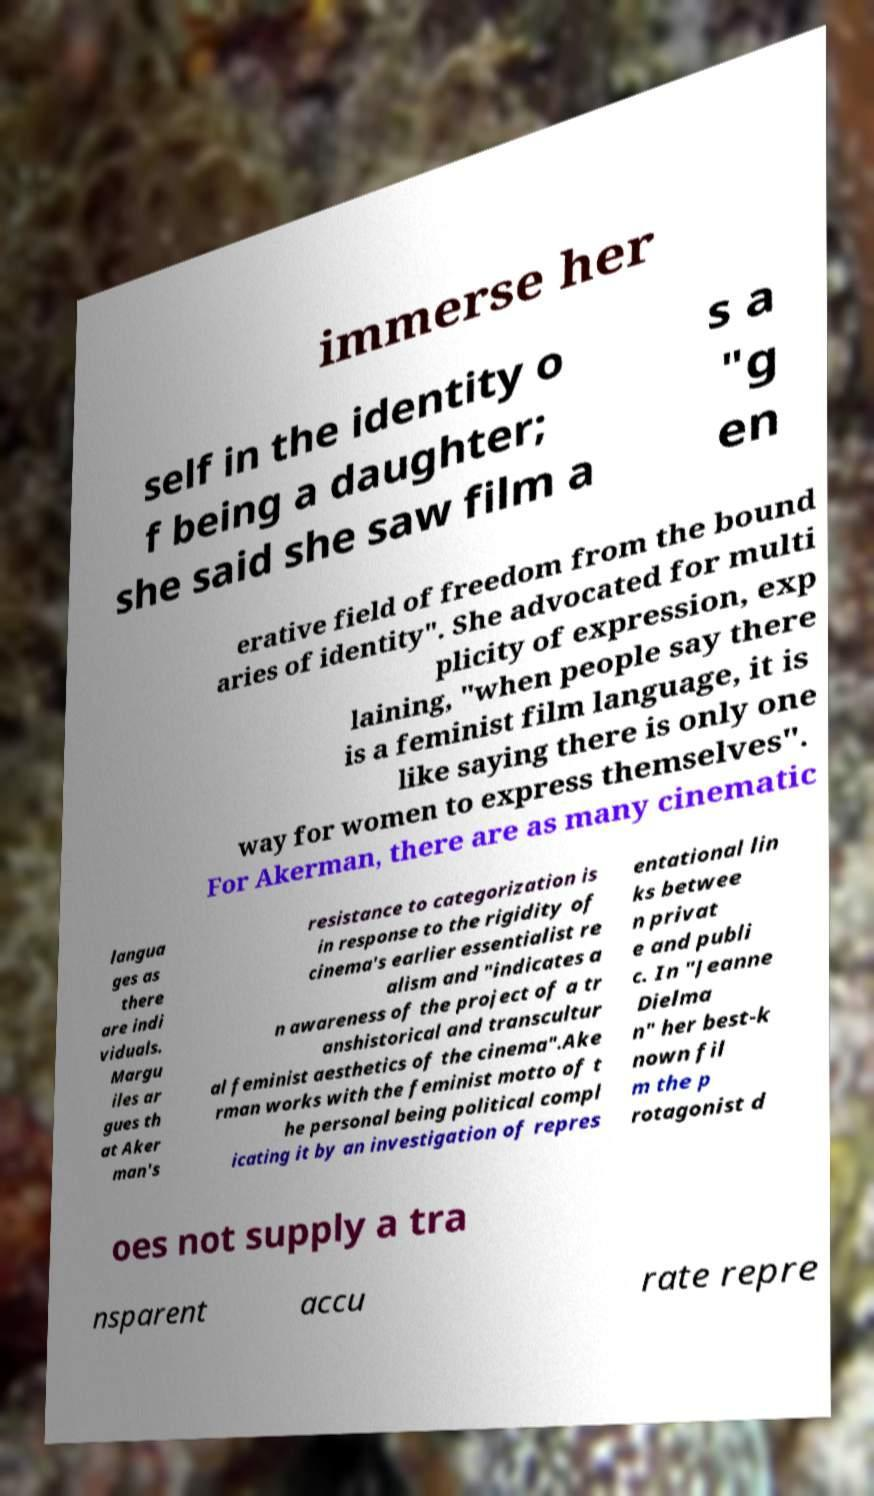Could you extract and type out the text from this image? immerse her self in the identity o f being a daughter; she said she saw film a s a "g en erative field of freedom from the bound aries of identity". She advocated for multi plicity of expression, exp laining, "when people say there is a feminist film language, it is like saying there is only one way for women to express themselves". For Akerman, there are as many cinematic langua ges as there are indi viduals. Margu iles ar gues th at Aker man's resistance to categorization is in response to the rigidity of cinema's earlier essentialist re alism and "indicates a n awareness of the project of a tr anshistorical and transcultur al feminist aesthetics of the cinema".Ake rman works with the feminist motto of t he personal being political compl icating it by an investigation of repres entational lin ks betwee n privat e and publi c. In "Jeanne Dielma n" her best-k nown fil m the p rotagonist d oes not supply a tra nsparent accu rate repre 